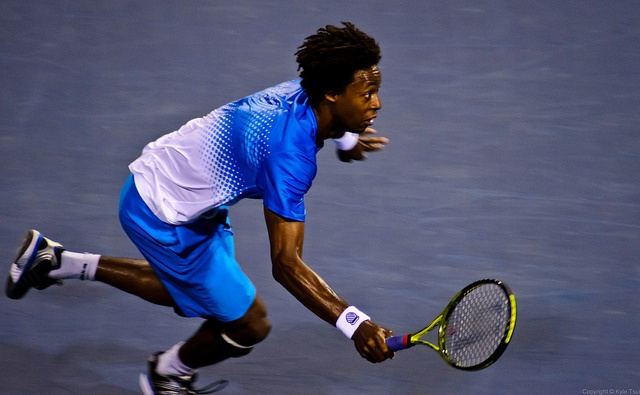Describe the objects in this image and their specific colors. I can see people in navy, black, darkblue, blue, and lavender tones and tennis racket in navy, gray, black, and darkgreen tones in this image. 